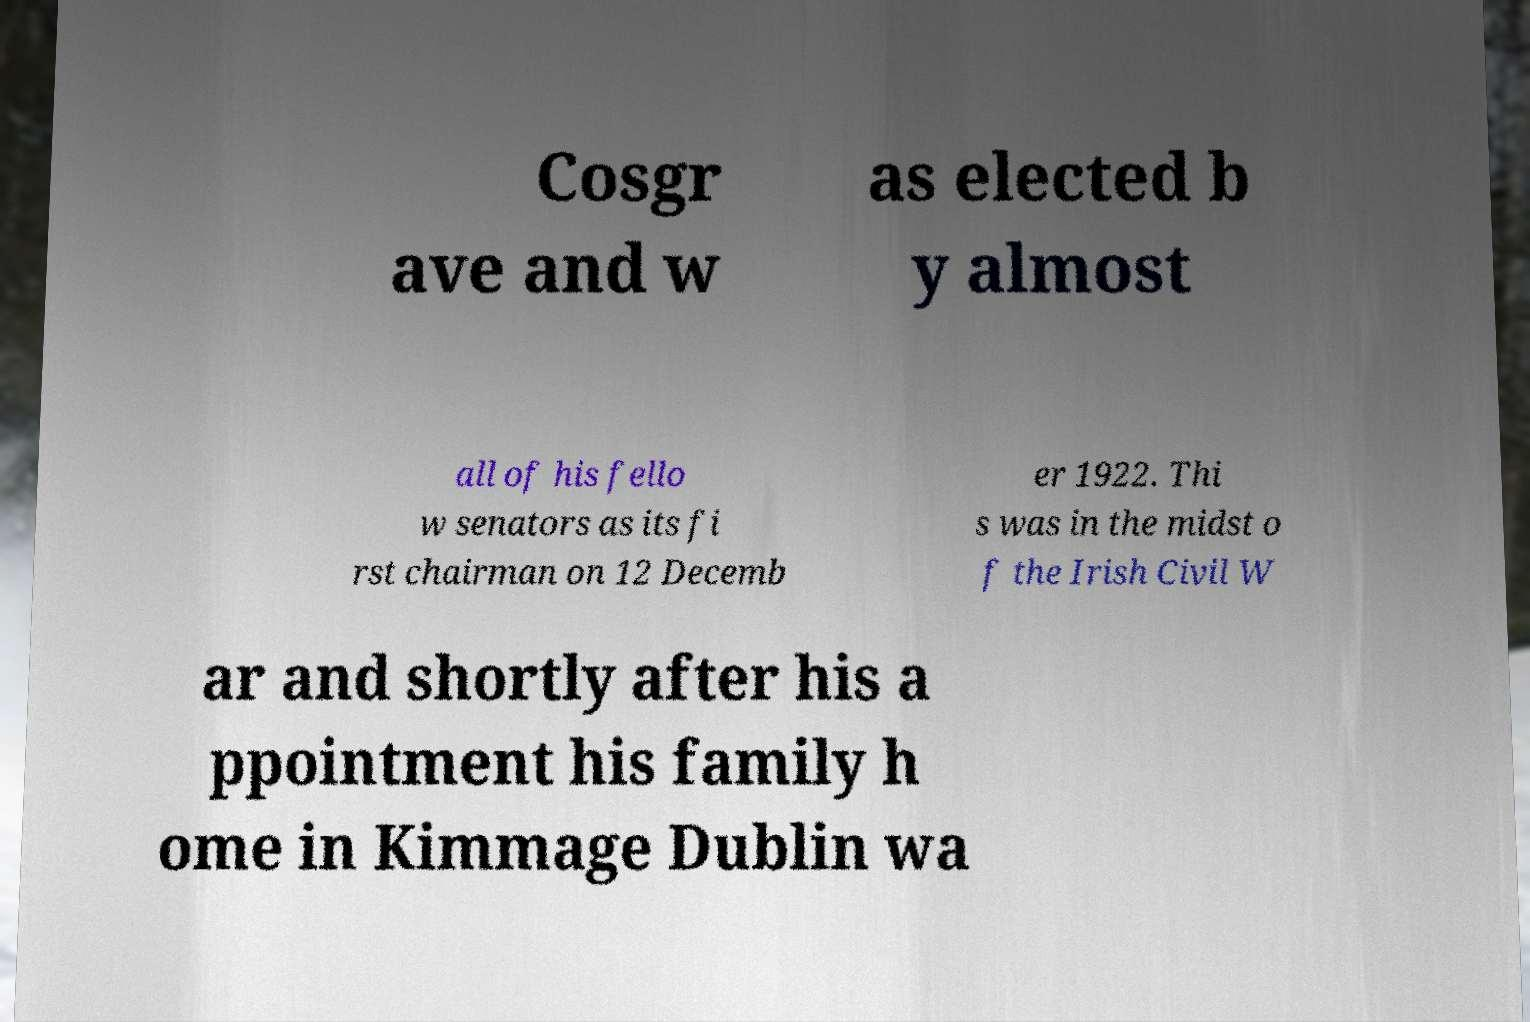Please identify and transcribe the text found in this image. Cosgr ave and w as elected b y almost all of his fello w senators as its fi rst chairman on 12 Decemb er 1922. Thi s was in the midst o f the Irish Civil W ar and shortly after his a ppointment his family h ome in Kimmage Dublin wa 